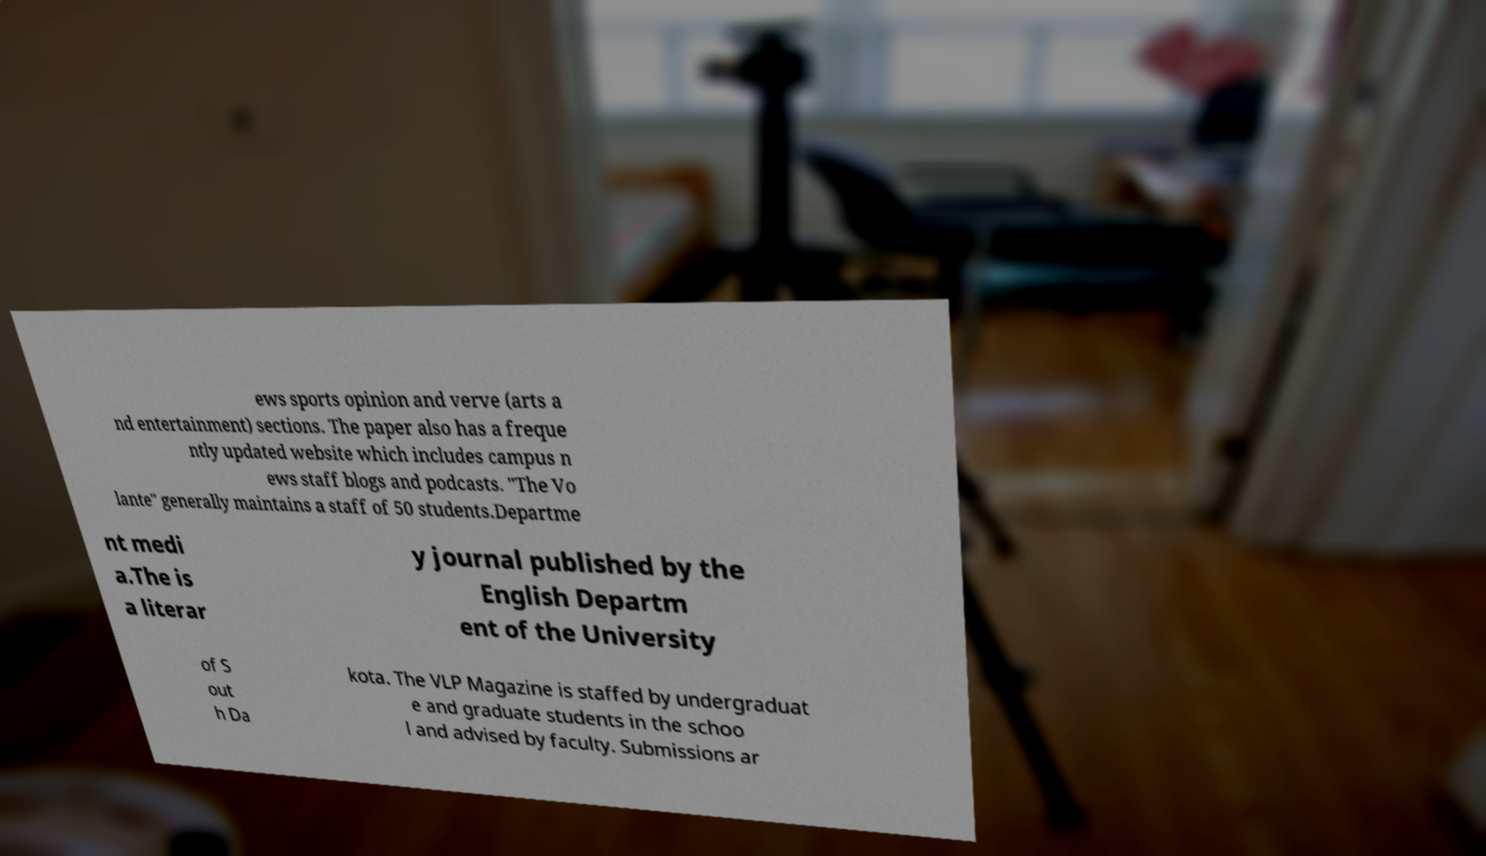What messages or text are displayed in this image? I need them in a readable, typed format. ews sports opinion and verve (arts a nd entertainment) sections. The paper also has a freque ntly updated website which includes campus n ews staff blogs and podcasts. "The Vo lante" generally maintains a staff of 50 students.Departme nt medi a.The is a literar y journal published by the English Departm ent of the University of S out h Da kota. The VLP Magazine is staffed by undergraduat e and graduate students in the schoo l and advised by faculty. Submissions ar 